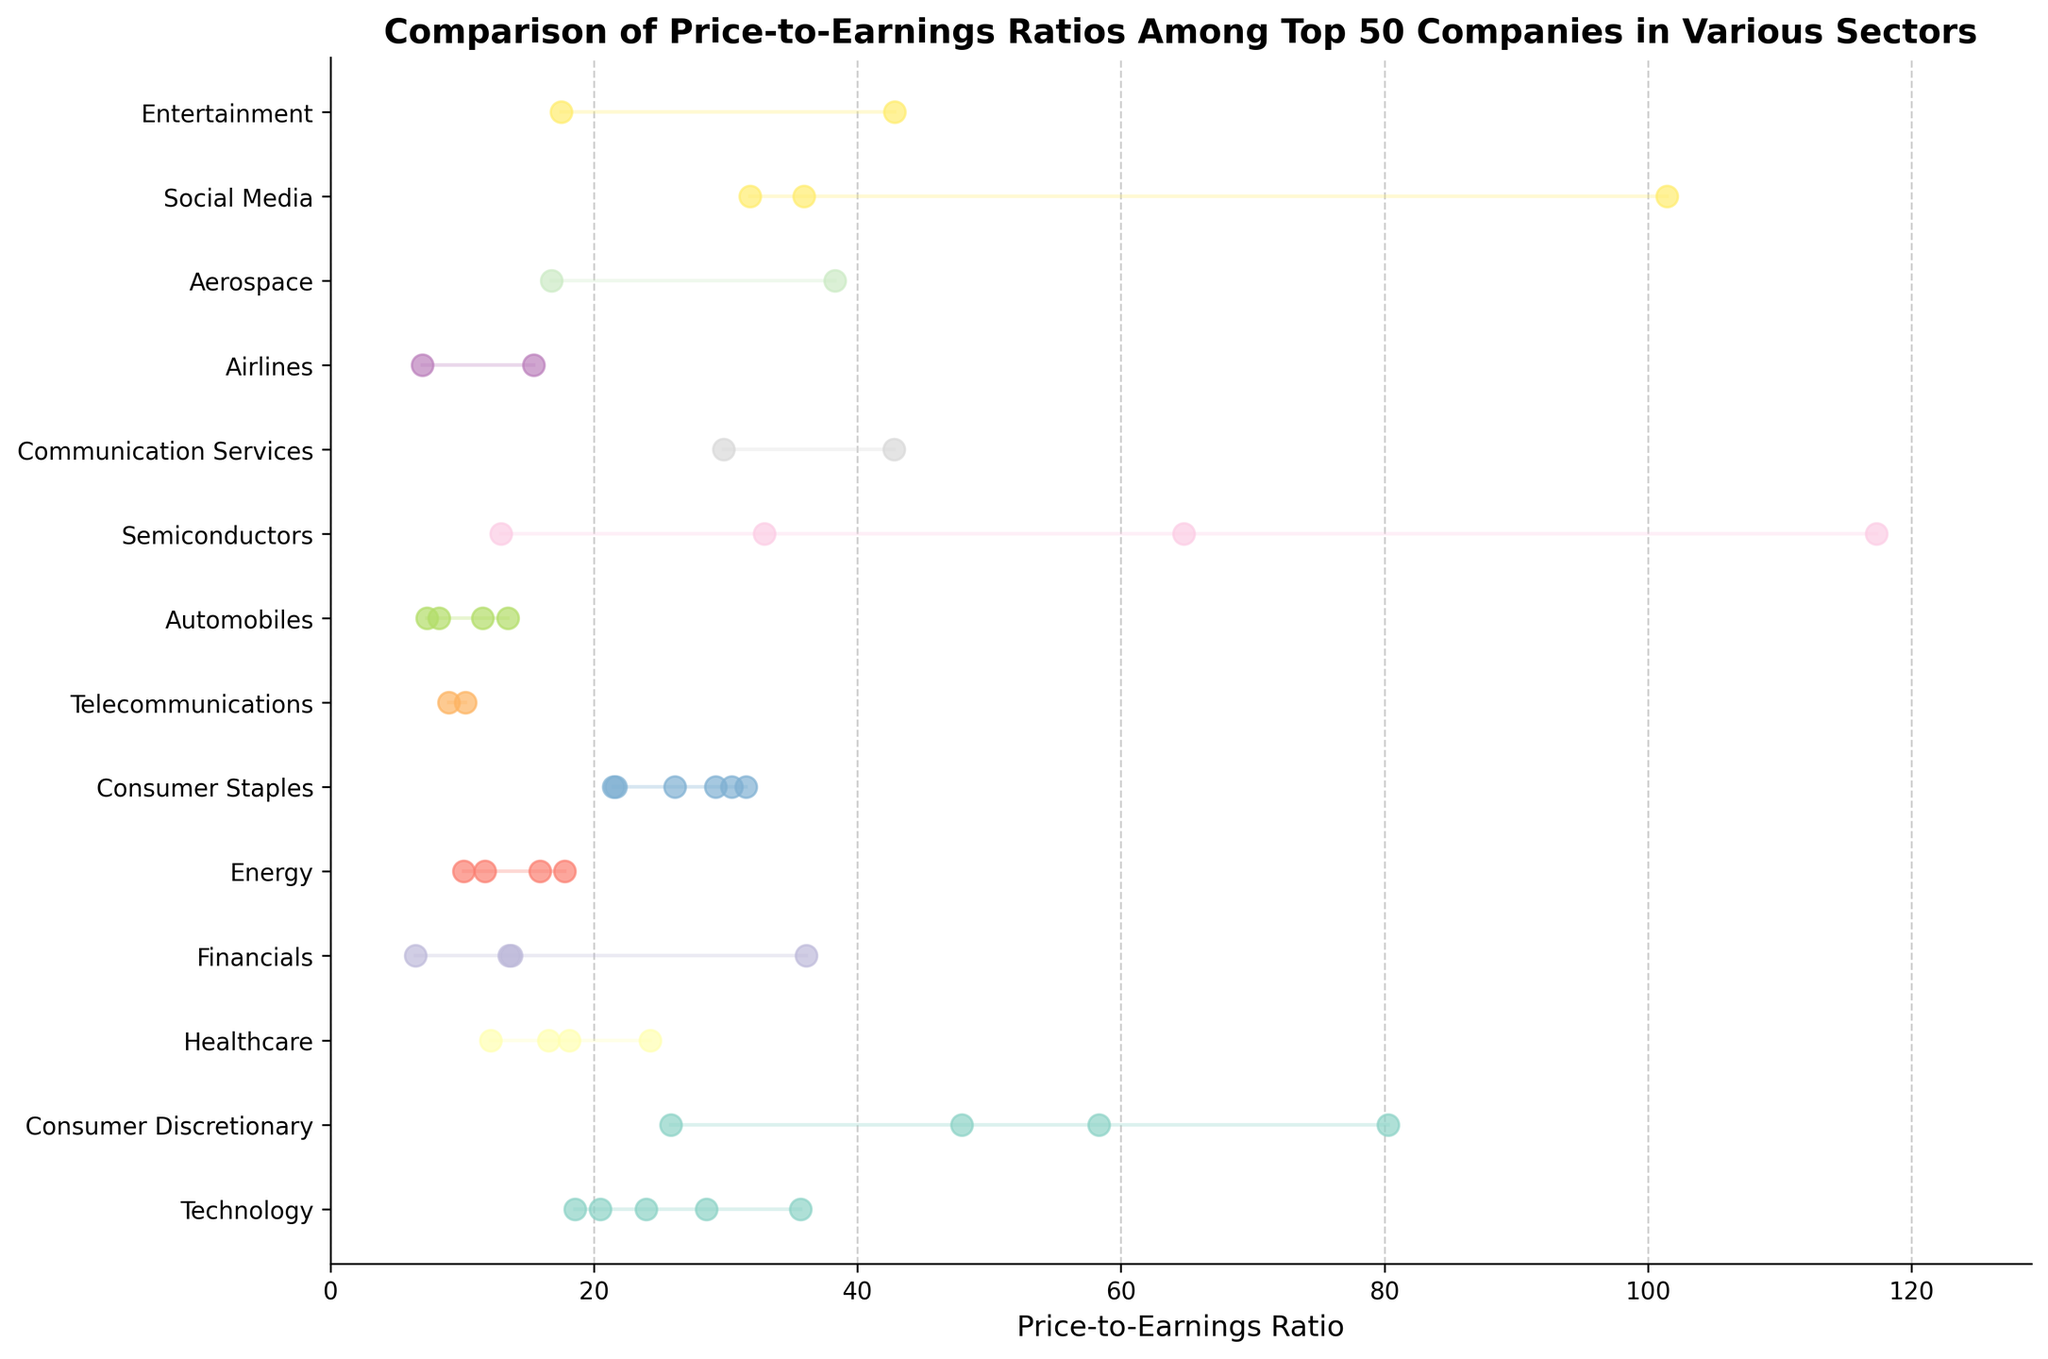What's the title of the figure? The title of the figure is displayed at the top and provides an overview of what the plot is about.
Answer: Comparison of Price-to-Earnings Ratios Among Top 50 Companies in Various Sectors Which sector has the highest average P/E ratio? To find the highest average P/E ratio, look at the sector whose dots (representing companies) are highest on average among all sectors.
Answer: Semiconductors How many sectors are represented in the figure? Identify the distinct sectors listed on the y-axis of the plot.
Answer: 10 Which company has the highest P/E ratio and in which sector is it? Locate the dot that is farthest to the right on the x-axis, then identify the corresponding company and sector from the plot.
Answer: AMD, Semiconductors What is the P/E ratio range for the Consumer Staples sector? Find the minimum and maximum P/E ratio dots within the Consumer Staples sector and note their values.
Answer: 21.47 to 31.56 Which two sectors have the widest range of P/E ratios? Compare the spans of P/E ratios (from minimum to maximum) within each sector and identify the two sectors with the largest ranges.
Answer: Consumer Discretionary and Semiconductors Which sector has the lowest minimum P/E ratio and what is the value? Identify the sector with the dot closest to zero on the x-axis and note the corresponding P/E ratio value.
Answer: Financials, 6.45 Compare the P/E ratios of Coca-Cola and PepsiCo. Which company has a higher P/E ratio and what's the difference? Find the dots representing Coca-Cola and PepsiCo in the Consumer Staples sector and subtract Coca-Cola's P/E ratio from PepsiCo's.
Answer: PepsiCo has a higher P/E ratio by 1.11 What is the average P/E ratio of the Technology sector? Add up the P/E ratios of all companies in the Technology sector, then divide by the number of Technology companies.
Answer: 25.92 What is the median P/E ratio in the Telecommunications sector? List the P/E ratios for companies in the Telecommunications sector, order them from lowest to highest, and find the middle value.
Answer: 9.61 